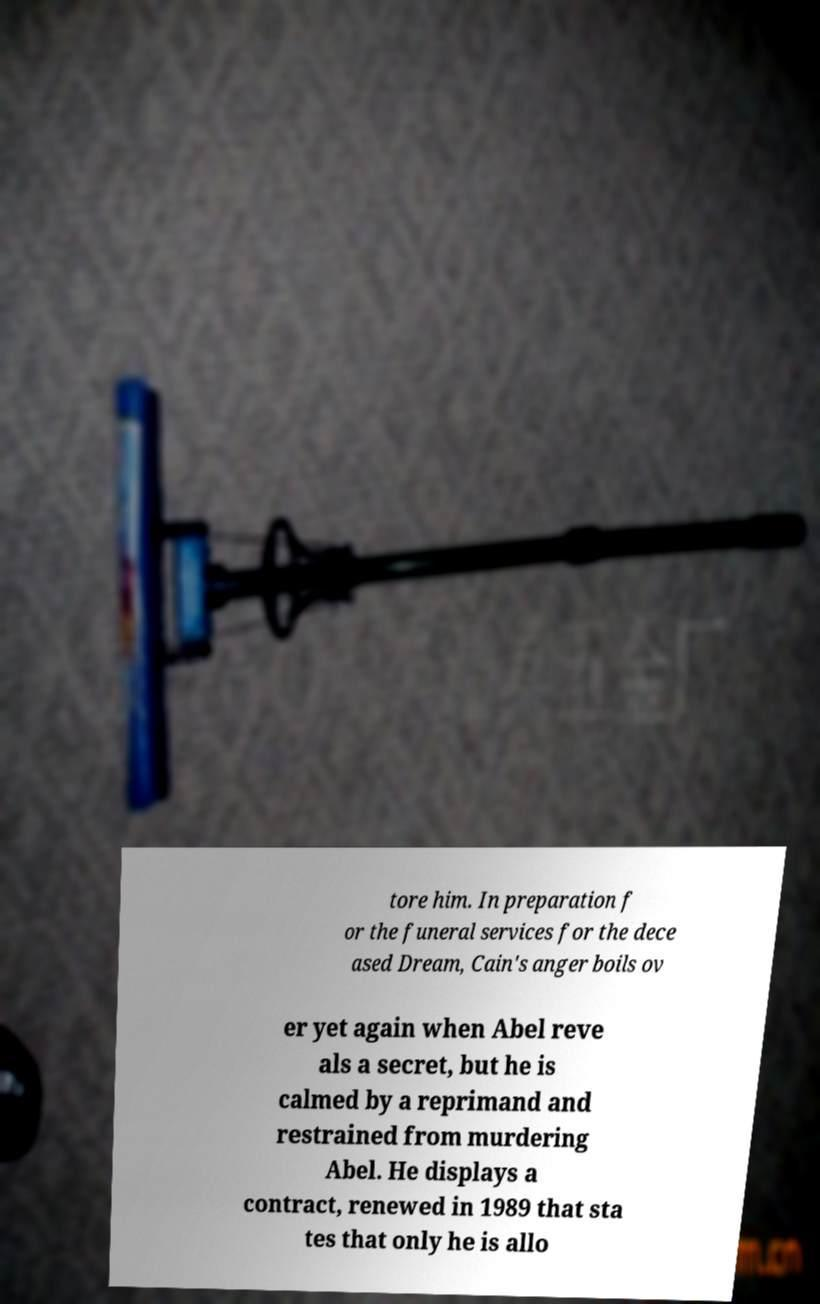Could you assist in decoding the text presented in this image and type it out clearly? tore him. In preparation f or the funeral services for the dece ased Dream, Cain's anger boils ov er yet again when Abel reve als a secret, but he is calmed by a reprimand and restrained from murdering Abel. He displays a contract, renewed in 1989 that sta tes that only he is allo 